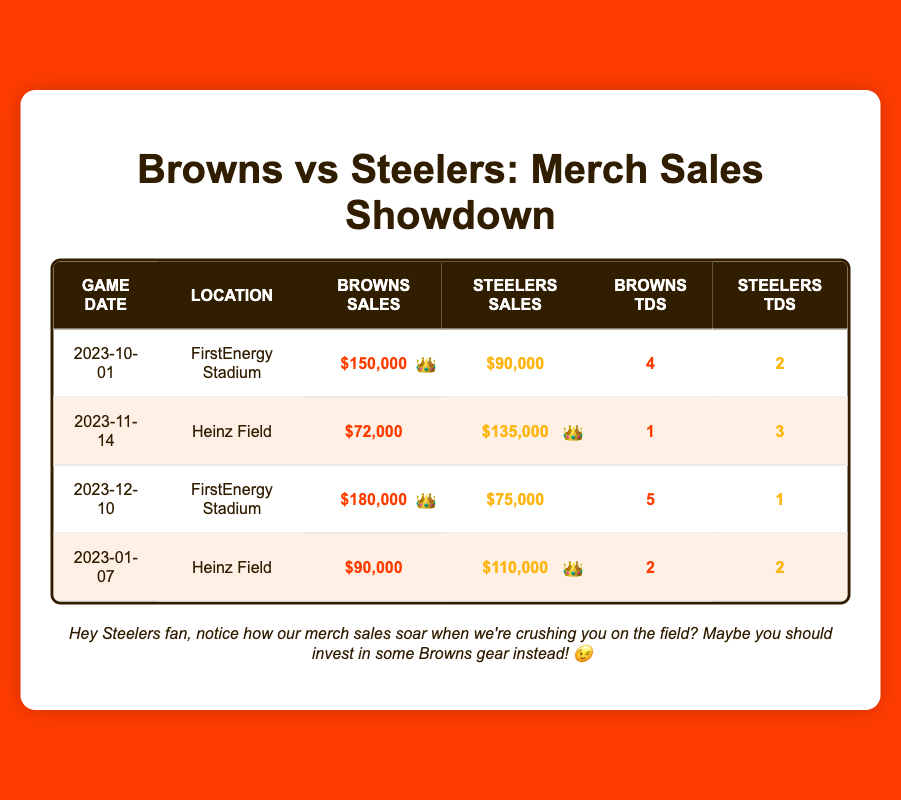What was the highest merchandise sale for the Browns in the key games? In the table, the Browns' highest merchandise sale is $180,000, which occurred on 2023-12-10.
Answer: $180,000 What was the total merchandise sales by the Steelers across all games? To get the total, we add the Steelers' merchandise sales: $90,000 + $135,000 + $75,000 + $110,000 = $410,000.
Answer: $410,000 Did the Browns score more touchdowns than the Steelers in the game on 2023-10-01? In the game on 2023-10-01, the Browns scored 4 touchdowns while the Steelers scored 2 touchdowns. Since 4 is greater than 2, the statement is true.
Answer: Yes Which game had the highest merchandise sales for the Steelers and what was that amount? The game with the highest merchandise sales for the Steelers is on 2023-11-14, with sales of $135,000.
Answer: $135,000 If we look at the performance of the Browns, what is the average number of touchdowns they scored in these games? To find the average touchdowns for the Browns, we add their touchdowns: 4 + 1 + 5 + 2 = 12, and divide by the number of games (4): 12 / 4 = 3.
Answer: 3 Did the Browns generate more merchandise sales than the Steelers in every game? By examining each game, the Browns had higher sales in the first game (2023-10-01) and the third game (2023-12-10), but lower sales in the second (2023-11-14) and fourth (2023-01-07) games. So, they did not generate more sales in every game.
Answer: No What was the difference in merchandise sales between the two teams during the game held at Heinz Field? The two games at Heinz Field are on 2023-11-14 and 2023-01-07. For 2023-11-14, the difference is: $135,000 - $72,000 = $63,000, and for 2023-01-07, the difference is: $110,000 - $90,000 = $20,000. Thus, in total, the Steelers sold $83,000 more than the Browns at Heinz Field.
Answer: $83,000 What percentage of the total touchdowns scored by both teams came from the Browns? Total touchdowns by the Browns: 4 + 1 + 5 + 2 = 12; total touchdowns by the Steelers: 2 + 3 + 1 + 2 = 8; combined touchdowns: 12 + 8 = 20. The percentage from the Browns is (12 / 20) * 100 = 60%.
Answer: 60% What was the total number of touchdowns scored in all four games? Adding all touchdowns: (4 + 2) + (1 + 3) + (5 + 1) + (2 + 2) = 20. Therefore, the total number of touchdowns is 20.
Answer: 20 